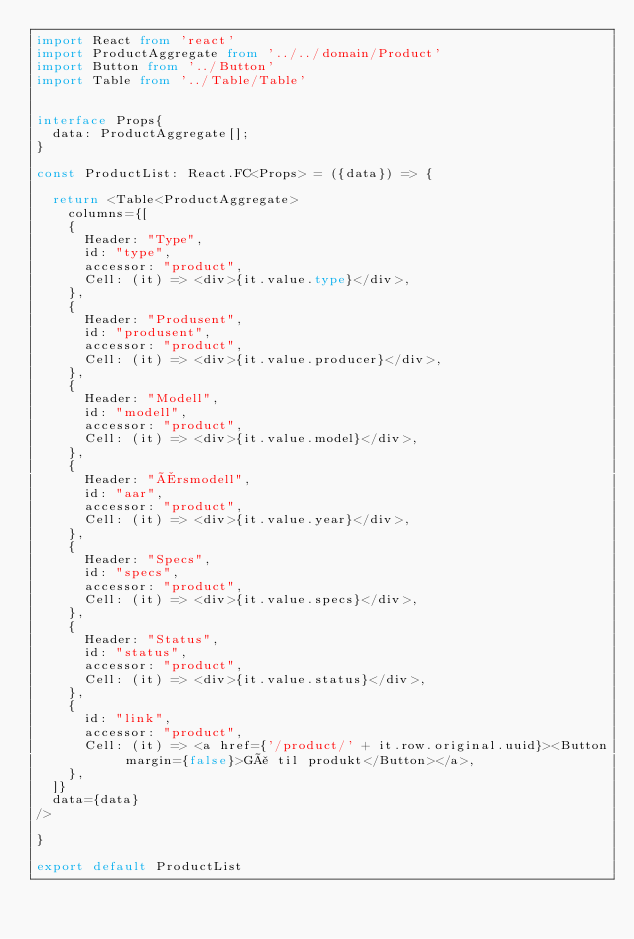Convert code to text. <code><loc_0><loc_0><loc_500><loc_500><_TypeScript_>import React from 'react'
import ProductAggregate from '../../domain/Product'
import Button from '../Button'
import Table from '../Table/Table'


interface Props{
  data: ProductAggregate[];
}

const ProductList: React.FC<Props> = ({data}) => {

  return <Table<ProductAggregate>
    columns={[
    {
      Header: "Type",
      id: "type",
      accessor: "product",
      Cell: (it) => <div>{it.value.type}</div>,
    },
    {
      Header: "Produsent",
      id: "produsent",
      accessor: "product",
      Cell: (it) => <div>{it.value.producer}</div>,
    },
    {
      Header: "Modell",
      id: "modell",
      accessor: "product",
      Cell: (it) => <div>{it.value.model}</div>,
    },
    {
      Header: "Årsmodell",
      id: "aar",
      accessor: "product",
      Cell: (it) => <div>{it.value.year}</div>,
    },
    {
      Header: "Specs",
      id: "specs",
      accessor: "product",
      Cell: (it) => <div>{it.value.specs}</div>,
    },
    {
      Header: "Status",
      id: "status",
      accessor: "product",
      Cell: (it) => <div>{it.value.status}</div>,
    },
    {
      id: "link",
      accessor: "product",
      Cell: (it) => <a href={'/product/' + it.row.original.uuid}><Button margin={false}>Gå til produkt</Button></a>,
    },
  ]}
  data={data}
/>

}

export default ProductList</code> 